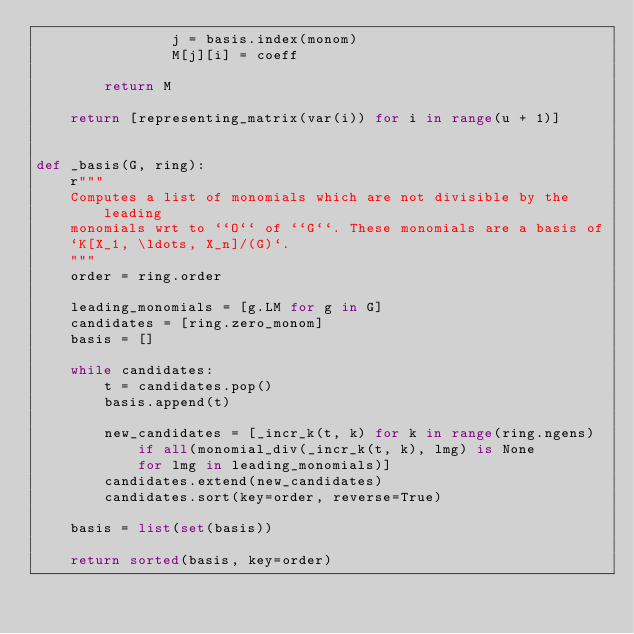<code> <loc_0><loc_0><loc_500><loc_500><_Python_>                j = basis.index(monom)
                M[j][i] = coeff

        return M

    return [representing_matrix(var(i)) for i in range(u + 1)]


def _basis(G, ring):
    r"""
    Computes a list of monomials which are not divisible by the leading
    monomials wrt to ``O`` of ``G``. These monomials are a basis of
    `K[X_1, \ldots, X_n]/(G)`.
    """
    order = ring.order

    leading_monomials = [g.LM for g in G]
    candidates = [ring.zero_monom]
    basis = []

    while candidates:
        t = candidates.pop()
        basis.append(t)

        new_candidates = [_incr_k(t, k) for k in range(ring.ngens)
            if all(monomial_div(_incr_k(t, k), lmg) is None
            for lmg in leading_monomials)]
        candidates.extend(new_candidates)
        candidates.sort(key=order, reverse=True)

    basis = list(set(basis))

    return sorted(basis, key=order)
</code> 